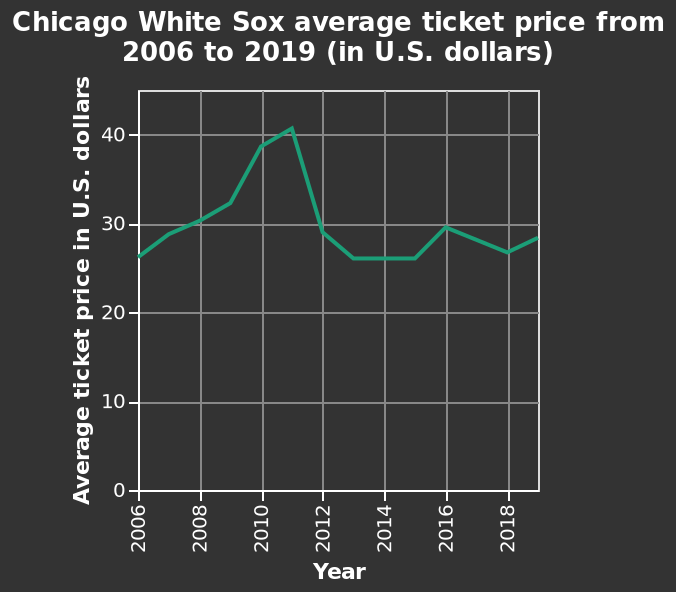<image>
What does the x-axis represent on the line diagram? The x-axis on the line diagram represents the years from 2006 to 2018. What does the y-axis represent on the line diagram? The y-axis on the line diagram represents the average ticket price in U.S. dollars ranging from 0 to 40. 